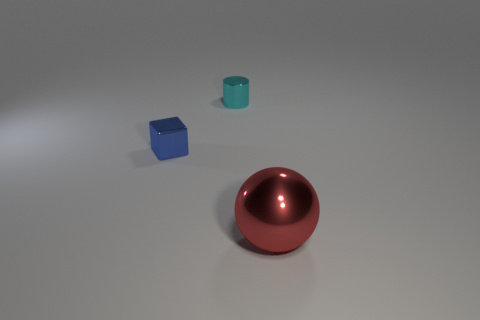Add 3 red rubber spheres. How many objects exist? 6 Add 3 tiny green matte cylinders. How many tiny green matte cylinders exist? 3 Subtract 0 brown cylinders. How many objects are left? 3 Subtract all cylinders. How many objects are left? 2 Subtract all yellow shiny things. Subtract all blue shiny cubes. How many objects are left? 2 Add 3 cyan objects. How many cyan objects are left? 4 